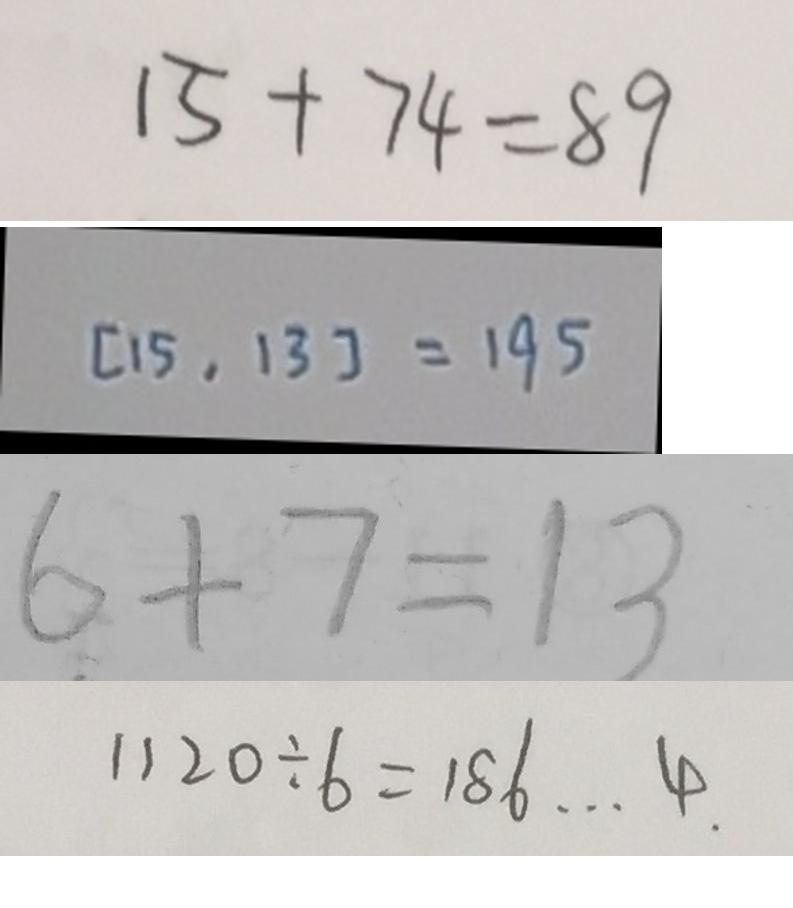Convert formula to latex. <formula><loc_0><loc_0><loc_500><loc_500>1 5 + 7 4 = 8 9 
 [ 1 5 , 1 3 ] = 1 9 5 
 6 + 7 = 1 3 
 1 1 2 0 \div 6 = 1 8 6 \cdots 4 .</formula> 